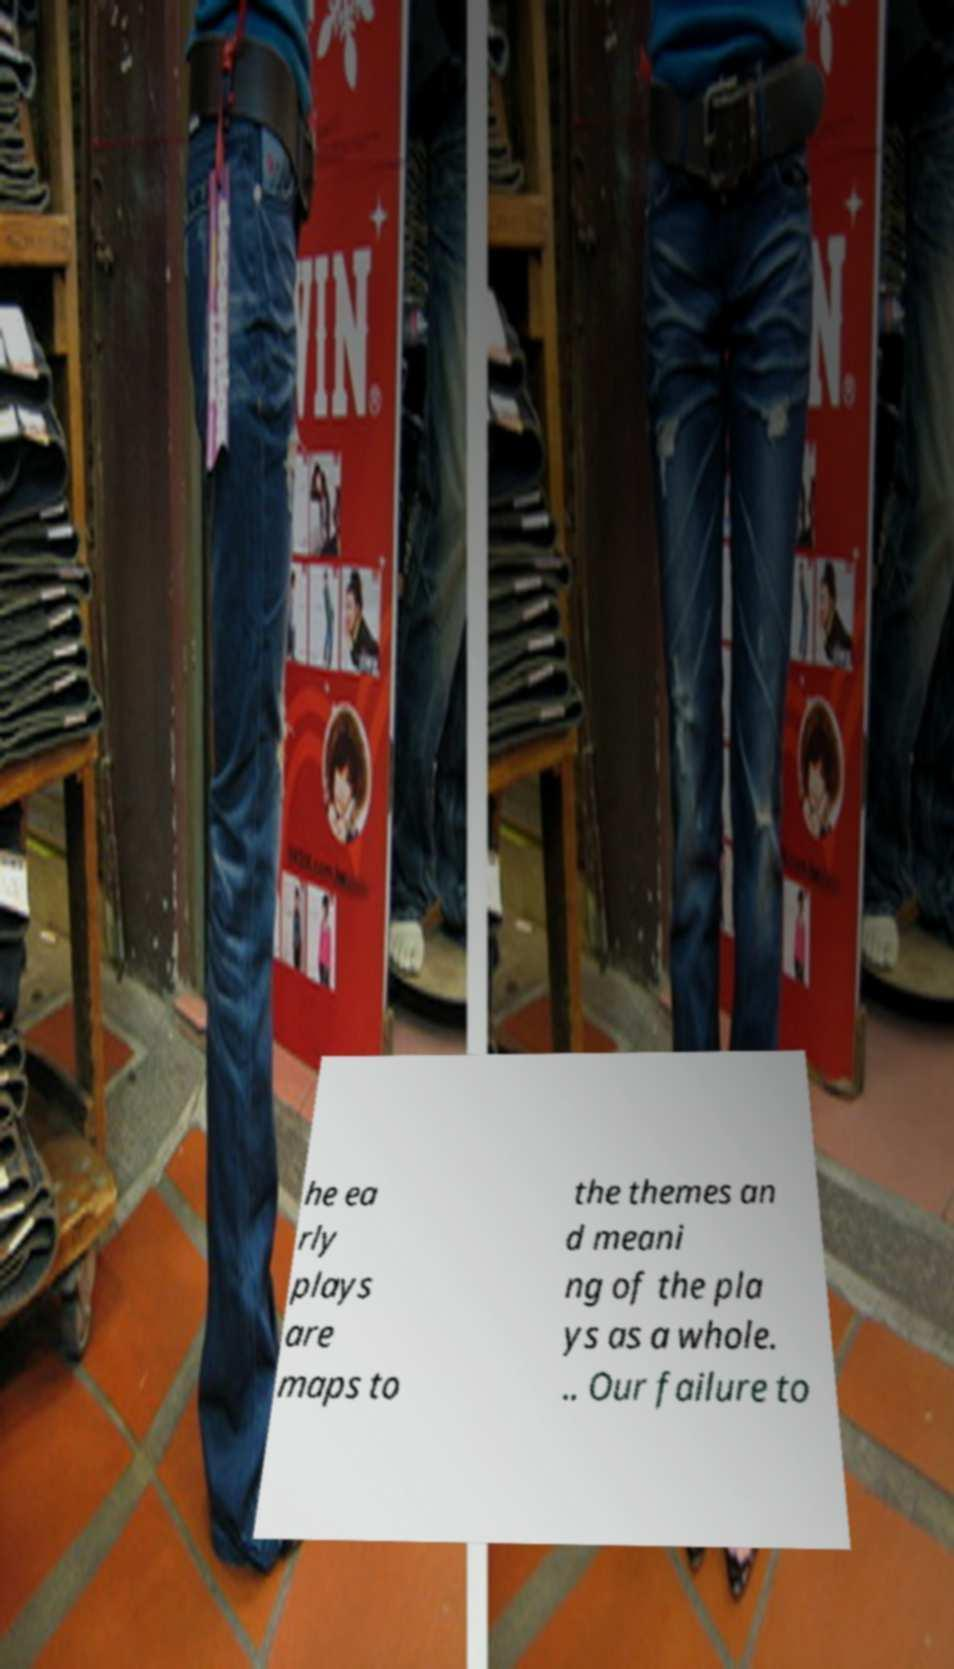Please identify and transcribe the text found in this image. he ea rly plays are maps to the themes an d meani ng of the pla ys as a whole. .. Our failure to 